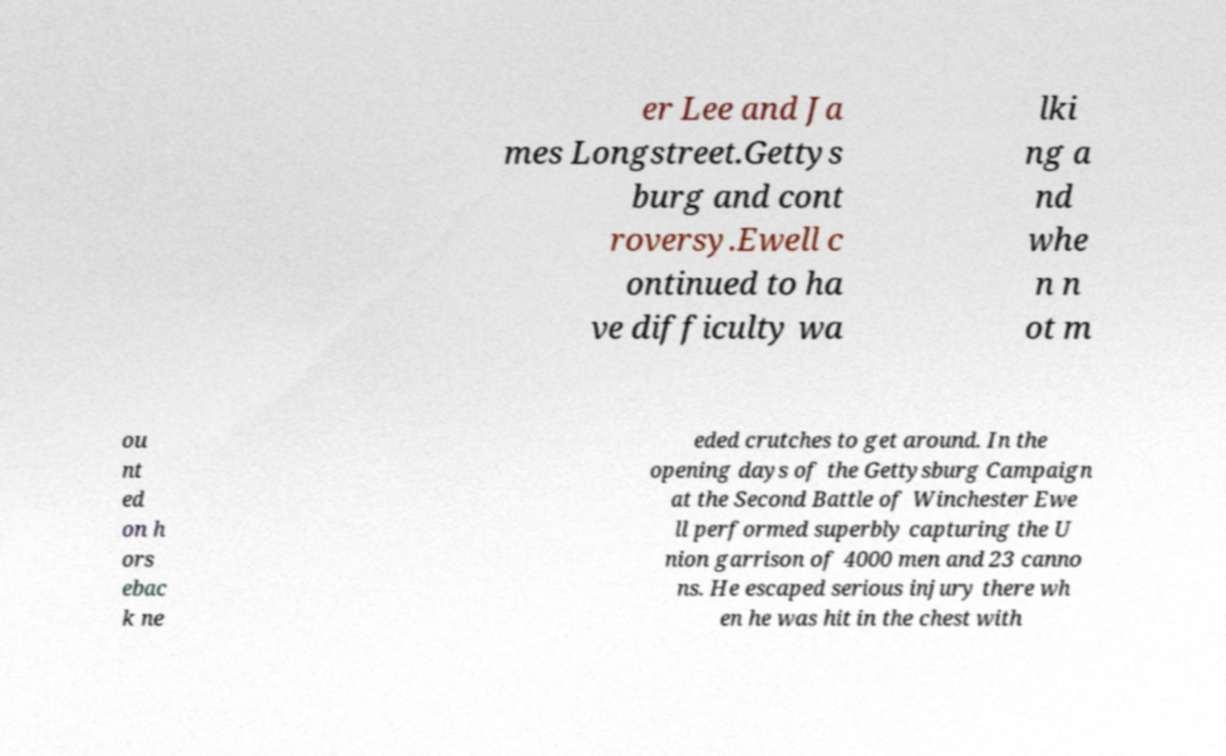Can you read and provide the text displayed in the image?This photo seems to have some interesting text. Can you extract and type it out for me? er Lee and Ja mes Longstreet.Gettys burg and cont roversy.Ewell c ontinued to ha ve difficulty wa lki ng a nd whe n n ot m ou nt ed on h ors ebac k ne eded crutches to get around. In the opening days of the Gettysburg Campaign at the Second Battle of Winchester Ewe ll performed superbly capturing the U nion garrison of 4000 men and 23 canno ns. He escaped serious injury there wh en he was hit in the chest with 